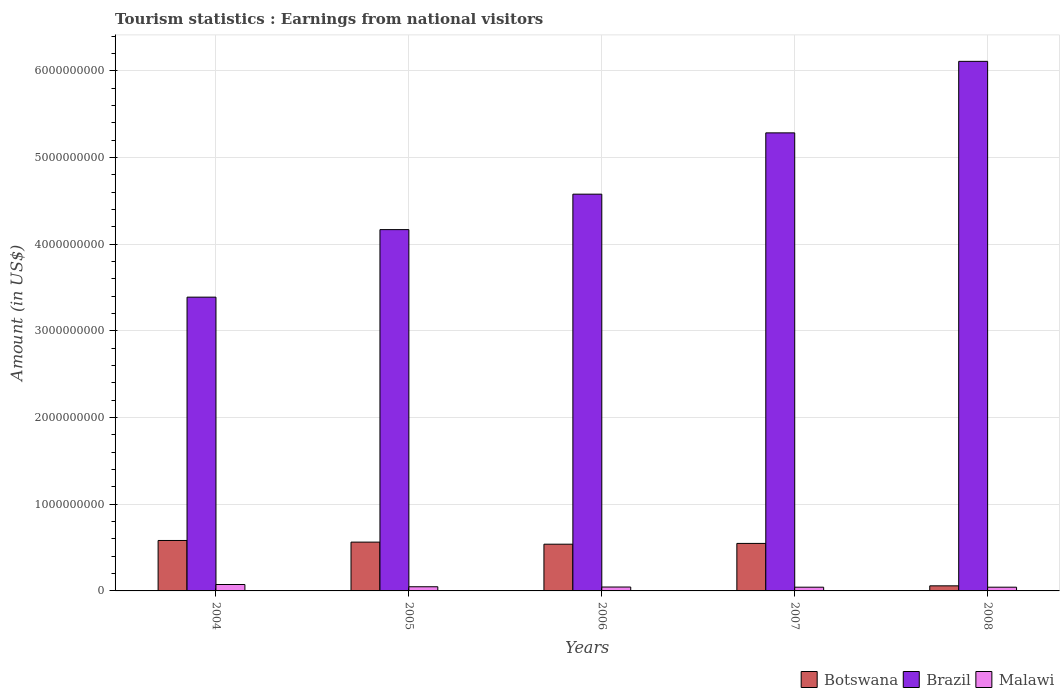Are the number of bars per tick equal to the number of legend labels?
Offer a very short reply. Yes. Are the number of bars on each tick of the X-axis equal?
Your answer should be compact. Yes. How many bars are there on the 3rd tick from the left?
Offer a very short reply. 3. How many bars are there on the 4th tick from the right?
Offer a very short reply. 3. What is the label of the 1st group of bars from the left?
Ensure brevity in your answer.  2004. In how many cases, is the number of bars for a given year not equal to the number of legend labels?
Provide a short and direct response. 0. What is the earnings from national visitors in Malawi in 2008?
Provide a succinct answer. 4.30e+07. Across all years, what is the maximum earnings from national visitors in Brazil?
Your response must be concise. 6.11e+09. Across all years, what is the minimum earnings from national visitors in Brazil?
Offer a terse response. 3.39e+09. In which year was the earnings from national visitors in Botswana minimum?
Your answer should be very brief. 2008. What is the total earnings from national visitors in Brazil in the graph?
Provide a short and direct response. 2.35e+1. What is the difference between the earnings from national visitors in Brazil in 2004 and that in 2007?
Make the answer very short. -1.90e+09. What is the difference between the earnings from national visitors in Brazil in 2008 and the earnings from national visitors in Botswana in 2004?
Your answer should be compact. 5.53e+09. What is the average earnings from national visitors in Malawi per year?
Ensure brevity in your answer.  5.06e+07. In the year 2007, what is the difference between the earnings from national visitors in Botswana and earnings from national visitors in Malawi?
Your response must be concise. 5.05e+08. In how many years, is the earnings from national visitors in Brazil greater than 4000000000 US$?
Your response must be concise. 4. What is the ratio of the earnings from national visitors in Brazil in 2005 to that in 2007?
Give a very brief answer. 0.79. Is the difference between the earnings from national visitors in Botswana in 2006 and 2007 greater than the difference between the earnings from national visitors in Malawi in 2006 and 2007?
Offer a very short reply. No. What is the difference between the highest and the second highest earnings from national visitors in Brazil?
Provide a succinct answer. 8.25e+08. What is the difference between the highest and the lowest earnings from national visitors in Brazil?
Offer a terse response. 2.72e+09. In how many years, is the earnings from national visitors in Brazil greater than the average earnings from national visitors in Brazil taken over all years?
Make the answer very short. 2. What does the 3rd bar from the left in 2004 represents?
Your answer should be very brief. Malawi. What does the 2nd bar from the right in 2006 represents?
Offer a terse response. Brazil. How many bars are there?
Offer a terse response. 15. Are all the bars in the graph horizontal?
Ensure brevity in your answer.  No. Are the values on the major ticks of Y-axis written in scientific E-notation?
Ensure brevity in your answer.  No. Does the graph contain grids?
Provide a succinct answer. Yes. Where does the legend appear in the graph?
Offer a very short reply. Bottom right. How many legend labels are there?
Your response must be concise. 3. What is the title of the graph?
Your response must be concise. Tourism statistics : Earnings from national visitors. What is the label or title of the X-axis?
Your answer should be compact. Years. What is the label or title of the Y-axis?
Give a very brief answer. Amount (in US$). What is the Amount (in US$) in Botswana in 2004?
Your response must be concise. 5.82e+08. What is the Amount (in US$) of Brazil in 2004?
Offer a terse response. 3.39e+09. What is the Amount (in US$) in Malawi in 2004?
Offer a terse response. 7.40e+07. What is the Amount (in US$) of Botswana in 2005?
Offer a very short reply. 5.63e+08. What is the Amount (in US$) in Brazil in 2005?
Your response must be concise. 4.17e+09. What is the Amount (in US$) of Malawi in 2005?
Provide a succinct answer. 4.80e+07. What is the Amount (in US$) in Botswana in 2006?
Give a very brief answer. 5.39e+08. What is the Amount (in US$) in Brazil in 2006?
Offer a terse response. 4.58e+09. What is the Amount (in US$) in Malawi in 2006?
Offer a terse response. 4.50e+07. What is the Amount (in US$) in Botswana in 2007?
Provide a short and direct response. 5.48e+08. What is the Amount (in US$) in Brazil in 2007?
Your answer should be compact. 5.28e+09. What is the Amount (in US$) in Malawi in 2007?
Your response must be concise. 4.30e+07. What is the Amount (in US$) of Botswana in 2008?
Ensure brevity in your answer.  5.87e+07. What is the Amount (in US$) in Brazil in 2008?
Provide a succinct answer. 6.11e+09. What is the Amount (in US$) in Malawi in 2008?
Your answer should be very brief. 4.30e+07. Across all years, what is the maximum Amount (in US$) of Botswana?
Keep it short and to the point. 5.82e+08. Across all years, what is the maximum Amount (in US$) in Brazil?
Make the answer very short. 6.11e+09. Across all years, what is the maximum Amount (in US$) of Malawi?
Your answer should be compact. 7.40e+07. Across all years, what is the minimum Amount (in US$) in Botswana?
Provide a short and direct response. 5.87e+07. Across all years, what is the minimum Amount (in US$) of Brazil?
Your answer should be compact. 3.39e+09. Across all years, what is the minimum Amount (in US$) in Malawi?
Make the answer very short. 4.30e+07. What is the total Amount (in US$) of Botswana in the graph?
Give a very brief answer. 2.29e+09. What is the total Amount (in US$) in Brazil in the graph?
Your answer should be very brief. 2.35e+1. What is the total Amount (in US$) of Malawi in the graph?
Ensure brevity in your answer.  2.53e+08. What is the difference between the Amount (in US$) of Botswana in 2004 and that in 2005?
Your answer should be compact. 1.90e+07. What is the difference between the Amount (in US$) of Brazil in 2004 and that in 2005?
Provide a short and direct response. -7.79e+08. What is the difference between the Amount (in US$) in Malawi in 2004 and that in 2005?
Ensure brevity in your answer.  2.60e+07. What is the difference between the Amount (in US$) in Botswana in 2004 and that in 2006?
Ensure brevity in your answer.  4.30e+07. What is the difference between the Amount (in US$) in Brazil in 2004 and that in 2006?
Give a very brief answer. -1.19e+09. What is the difference between the Amount (in US$) in Malawi in 2004 and that in 2006?
Your response must be concise. 2.90e+07. What is the difference between the Amount (in US$) of Botswana in 2004 and that in 2007?
Your answer should be very brief. 3.40e+07. What is the difference between the Amount (in US$) in Brazil in 2004 and that in 2007?
Offer a very short reply. -1.90e+09. What is the difference between the Amount (in US$) in Malawi in 2004 and that in 2007?
Provide a succinct answer. 3.10e+07. What is the difference between the Amount (in US$) of Botswana in 2004 and that in 2008?
Keep it short and to the point. 5.23e+08. What is the difference between the Amount (in US$) of Brazil in 2004 and that in 2008?
Make the answer very short. -2.72e+09. What is the difference between the Amount (in US$) of Malawi in 2004 and that in 2008?
Your response must be concise. 3.10e+07. What is the difference between the Amount (in US$) in Botswana in 2005 and that in 2006?
Offer a very short reply. 2.40e+07. What is the difference between the Amount (in US$) of Brazil in 2005 and that in 2006?
Offer a terse response. -4.09e+08. What is the difference between the Amount (in US$) of Botswana in 2005 and that in 2007?
Offer a very short reply. 1.50e+07. What is the difference between the Amount (in US$) in Brazil in 2005 and that in 2007?
Ensure brevity in your answer.  -1.12e+09. What is the difference between the Amount (in US$) of Botswana in 2005 and that in 2008?
Ensure brevity in your answer.  5.04e+08. What is the difference between the Amount (in US$) of Brazil in 2005 and that in 2008?
Give a very brief answer. -1.94e+09. What is the difference between the Amount (in US$) in Malawi in 2005 and that in 2008?
Provide a short and direct response. 5.00e+06. What is the difference between the Amount (in US$) in Botswana in 2006 and that in 2007?
Offer a terse response. -9.00e+06. What is the difference between the Amount (in US$) of Brazil in 2006 and that in 2007?
Ensure brevity in your answer.  -7.07e+08. What is the difference between the Amount (in US$) of Malawi in 2006 and that in 2007?
Keep it short and to the point. 2.00e+06. What is the difference between the Amount (in US$) in Botswana in 2006 and that in 2008?
Make the answer very short. 4.80e+08. What is the difference between the Amount (in US$) of Brazil in 2006 and that in 2008?
Provide a short and direct response. -1.53e+09. What is the difference between the Amount (in US$) in Botswana in 2007 and that in 2008?
Make the answer very short. 4.89e+08. What is the difference between the Amount (in US$) of Brazil in 2007 and that in 2008?
Your answer should be compact. -8.25e+08. What is the difference between the Amount (in US$) in Botswana in 2004 and the Amount (in US$) in Brazil in 2005?
Your response must be concise. -3.59e+09. What is the difference between the Amount (in US$) in Botswana in 2004 and the Amount (in US$) in Malawi in 2005?
Make the answer very short. 5.34e+08. What is the difference between the Amount (in US$) in Brazil in 2004 and the Amount (in US$) in Malawi in 2005?
Give a very brief answer. 3.34e+09. What is the difference between the Amount (in US$) in Botswana in 2004 and the Amount (in US$) in Brazil in 2006?
Offer a very short reply. -4.00e+09. What is the difference between the Amount (in US$) of Botswana in 2004 and the Amount (in US$) of Malawi in 2006?
Make the answer very short. 5.37e+08. What is the difference between the Amount (in US$) of Brazil in 2004 and the Amount (in US$) of Malawi in 2006?
Provide a short and direct response. 3.34e+09. What is the difference between the Amount (in US$) of Botswana in 2004 and the Amount (in US$) of Brazil in 2007?
Your answer should be compact. -4.70e+09. What is the difference between the Amount (in US$) in Botswana in 2004 and the Amount (in US$) in Malawi in 2007?
Ensure brevity in your answer.  5.39e+08. What is the difference between the Amount (in US$) of Brazil in 2004 and the Amount (in US$) of Malawi in 2007?
Make the answer very short. 3.35e+09. What is the difference between the Amount (in US$) in Botswana in 2004 and the Amount (in US$) in Brazil in 2008?
Your answer should be very brief. -5.53e+09. What is the difference between the Amount (in US$) of Botswana in 2004 and the Amount (in US$) of Malawi in 2008?
Your answer should be compact. 5.39e+08. What is the difference between the Amount (in US$) in Brazil in 2004 and the Amount (in US$) in Malawi in 2008?
Offer a terse response. 3.35e+09. What is the difference between the Amount (in US$) in Botswana in 2005 and the Amount (in US$) in Brazil in 2006?
Ensure brevity in your answer.  -4.01e+09. What is the difference between the Amount (in US$) of Botswana in 2005 and the Amount (in US$) of Malawi in 2006?
Ensure brevity in your answer.  5.18e+08. What is the difference between the Amount (in US$) of Brazil in 2005 and the Amount (in US$) of Malawi in 2006?
Ensure brevity in your answer.  4.12e+09. What is the difference between the Amount (in US$) in Botswana in 2005 and the Amount (in US$) in Brazil in 2007?
Give a very brief answer. -4.72e+09. What is the difference between the Amount (in US$) of Botswana in 2005 and the Amount (in US$) of Malawi in 2007?
Your response must be concise. 5.20e+08. What is the difference between the Amount (in US$) in Brazil in 2005 and the Amount (in US$) in Malawi in 2007?
Give a very brief answer. 4.12e+09. What is the difference between the Amount (in US$) of Botswana in 2005 and the Amount (in US$) of Brazil in 2008?
Provide a succinct answer. -5.55e+09. What is the difference between the Amount (in US$) in Botswana in 2005 and the Amount (in US$) in Malawi in 2008?
Give a very brief answer. 5.20e+08. What is the difference between the Amount (in US$) in Brazil in 2005 and the Amount (in US$) in Malawi in 2008?
Offer a terse response. 4.12e+09. What is the difference between the Amount (in US$) of Botswana in 2006 and the Amount (in US$) of Brazil in 2007?
Offer a very short reply. -4.74e+09. What is the difference between the Amount (in US$) in Botswana in 2006 and the Amount (in US$) in Malawi in 2007?
Offer a very short reply. 4.96e+08. What is the difference between the Amount (in US$) in Brazil in 2006 and the Amount (in US$) in Malawi in 2007?
Provide a short and direct response. 4.53e+09. What is the difference between the Amount (in US$) of Botswana in 2006 and the Amount (in US$) of Brazil in 2008?
Ensure brevity in your answer.  -5.57e+09. What is the difference between the Amount (in US$) of Botswana in 2006 and the Amount (in US$) of Malawi in 2008?
Make the answer very short. 4.96e+08. What is the difference between the Amount (in US$) of Brazil in 2006 and the Amount (in US$) of Malawi in 2008?
Provide a short and direct response. 4.53e+09. What is the difference between the Amount (in US$) in Botswana in 2007 and the Amount (in US$) in Brazil in 2008?
Offer a terse response. -5.56e+09. What is the difference between the Amount (in US$) in Botswana in 2007 and the Amount (in US$) in Malawi in 2008?
Your response must be concise. 5.05e+08. What is the difference between the Amount (in US$) in Brazil in 2007 and the Amount (in US$) in Malawi in 2008?
Your answer should be compact. 5.24e+09. What is the average Amount (in US$) in Botswana per year?
Ensure brevity in your answer.  4.58e+08. What is the average Amount (in US$) of Brazil per year?
Offer a terse response. 4.71e+09. What is the average Amount (in US$) of Malawi per year?
Offer a terse response. 5.06e+07. In the year 2004, what is the difference between the Amount (in US$) in Botswana and Amount (in US$) in Brazil?
Your answer should be very brief. -2.81e+09. In the year 2004, what is the difference between the Amount (in US$) in Botswana and Amount (in US$) in Malawi?
Offer a very short reply. 5.08e+08. In the year 2004, what is the difference between the Amount (in US$) of Brazil and Amount (in US$) of Malawi?
Make the answer very short. 3.32e+09. In the year 2005, what is the difference between the Amount (in US$) in Botswana and Amount (in US$) in Brazil?
Keep it short and to the point. -3.60e+09. In the year 2005, what is the difference between the Amount (in US$) in Botswana and Amount (in US$) in Malawi?
Ensure brevity in your answer.  5.15e+08. In the year 2005, what is the difference between the Amount (in US$) of Brazil and Amount (in US$) of Malawi?
Offer a terse response. 4.12e+09. In the year 2006, what is the difference between the Amount (in US$) in Botswana and Amount (in US$) in Brazil?
Offer a very short reply. -4.04e+09. In the year 2006, what is the difference between the Amount (in US$) of Botswana and Amount (in US$) of Malawi?
Make the answer very short. 4.94e+08. In the year 2006, what is the difference between the Amount (in US$) in Brazil and Amount (in US$) in Malawi?
Your answer should be very brief. 4.53e+09. In the year 2007, what is the difference between the Amount (in US$) in Botswana and Amount (in US$) in Brazil?
Make the answer very short. -4.74e+09. In the year 2007, what is the difference between the Amount (in US$) in Botswana and Amount (in US$) in Malawi?
Provide a short and direct response. 5.05e+08. In the year 2007, what is the difference between the Amount (in US$) in Brazil and Amount (in US$) in Malawi?
Ensure brevity in your answer.  5.24e+09. In the year 2008, what is the difference between the Amount (in US$) in Botswana and Amount (in US$) in Brazil?
Provide a succinct answer. -6.05e+09. In the year 2008, what is the difference between the Amount (in US$) of Botswana and Amount (in US$) of Malawi?
Your answer should be very brief. 1.57e+07. In the year 2008, what is the difference between the Amount (in US$) of Brazil and Amount (in US$) of Malawi?
Offer a terse response. 6.07e+09. What is the ratio of the Amount (in US$) in Botswana in 2004 to that in 2005?
Your answer should be compact. 1.03. What is the ratio of the Amount (in US$) in Brazil in 2004 to that in 2005?
Make the answer very short. 0.81. What is the ratio of the Amount (in US$) of Malawi in 2004 to that in 2005?
Keep it short and to the point. 1.54. What is the ratio of the Amount (in US$) in Botswana in 2004 to that in 2006?
Give a very brief answer. 1.08. What is the ratio of the Amount (in US$) in Brazil in 2004 to that in 2006?
Provide a short and direct response. 0.74. What is the ratio of the Amount (in US$) of Malawi in 2004 to that in 2006?
Give a very brief answer. 1.64. What is the ratio of the Amount (in US$) in Botswana in 2004 to that in 2007?
Give a very brief answer. 1.06. What is the ratio of the Amount (in US$) in Brazil in 2004 to that in 2007?
Provide a succinct answer. 0.64. What is the ratio of the Amount (in US$) of Malawi in 2004 to that in 2007?
Your response must be concise. 1.72. What is the ratio of the Amount (in US$) in Botswana in 2004 to that in 2008?
Your answer should be very brief. 9.91. What is the ratio of the Amount (in US$) in Brazil in 2004 to that in 2008?
Offer a terse response. 0.55. What is the ratio of the Amount (in US$) of Malawi in 2004 to that in 2008?
Ensure brevity in your answer.  1.72. What is the ratio of the Amount (in US$) of Botswana in 2005 to that in 2006?
Your answer should be compact. 1.04. What is the ratio of the Amount (in US$) in Brazil in 2005 to that in 2006?
Your response must be concise. 0.91. What is the ratio of the Amount (in US$) in Malawi in 2005 to that in 2006?
Ensure brevity in your answer.  1.07. What is the ratio of the Amount (in US$) in Botswana in 2005 to that in 2007?
Your answer should be compact. 1.03. What is the ratio of the Amount (in US$) in Brazil in 2005 to that in 2007?
Your answer should be very brief. 0.79. What is the ratio of the Amount (in US$) in Malawi in 2005 to that in 2007?
Give a very brief answer. 1.12. What is the ratio of the Amount (in US$) in Botswana in 2005 to that in 2008?
Your answer should be very brief. 9.59. What is the ratio of the Amount (in US$) of Brazil in 2005 to that in 2008?
Provide a succinct answer. 0.68. What is the ratio of the Amount (in US$) in Malawi in 2005 to that in 2008?
Your response must be concise. 1.12. What is the ratio of the Amount (in US$) in Botswana in 2006 to that in 2007?
Give a very brief answer. 0.98. What is the ratio of the Amount (in US$) in Brazil in 2006 to that in 2007?
Provide a short and direct response. 0.87. What is the ratio of the Amount (in US$) in Malawi in 2006 to that in 2007?
Make the answer very short. 1.05. What is the ratio of the Amount (in US$) in Botswana in 2006 to that in 2008?
Make the answer very short. 9.18. What is the ratio of the Amount (in US$) of Brazil in 2006 to that in 2008?
Give a very brief answer. 0.75. What is the ratio of the Amount (in US$) in Malawi in 2006 to that in 2008?
Offer a very short reply. 1.05. What is the ratio of the Amount (in US$) of Botswana in 2007 to that in 2008?
Your answer should be compact. 9.34. What is the ratio of the Amount (in US$) in Brazil in 2007 to that in 2008?
Your response must be concise. 0.86. What is the difference between the highest and the second highest Amount (in US$) in Botswana?
Your response must be concise. 1.90e+07. What is the difference between the highest and the second highest Amount (in US$) in Brazil?
Your answer should be very brief. 8.25e+08. What is the difference between the highest and the second highest Amount (in US$) in Malawi?
Ensure brevity in your answer.  2.60e+07. What is the difference between the highest and the lowest Amount (in US$) in Botswana?
Your response must be concise. 5.23e+08. What is the difference between the highest and the lowest Amount (in US$) in Brazil?
Give a very brief answer. 2.72e+09. What is the difference between the highest and the lowest Amount (in US$) in Malawi?
Your answer should be compact. 3.10e+07. 